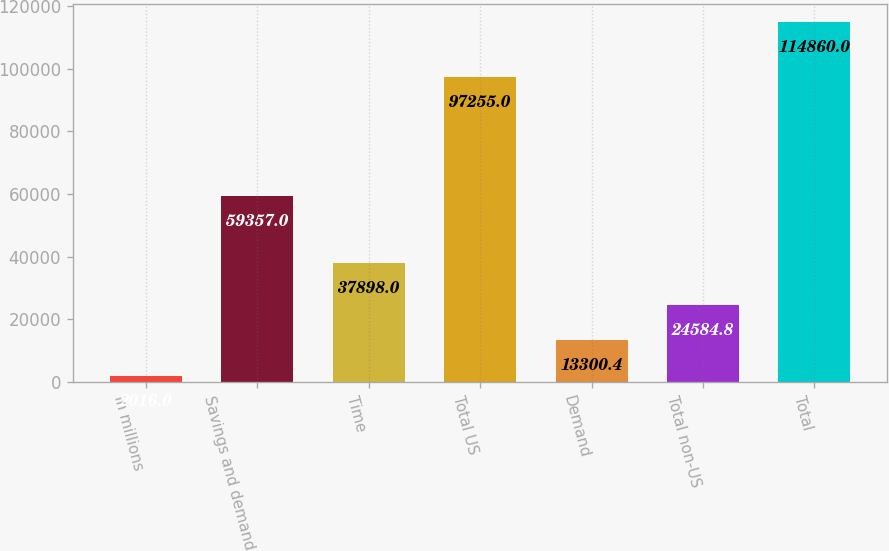Convert chart to OTSL. <chart><loc_0><loc_0><loc_500><loc_500><bar_chart><fcel>in millions<fcel>Savings and demand<fcel>Time<fcel>Total US<fcel>Demand<fcel>Total non-US<fcel>Total<nl><fcel>2016<fcel>59357<fcel>37898<fcel>97255<fcel>13300.4<fcel>24584.8<fcel>114860<nl></chart> 